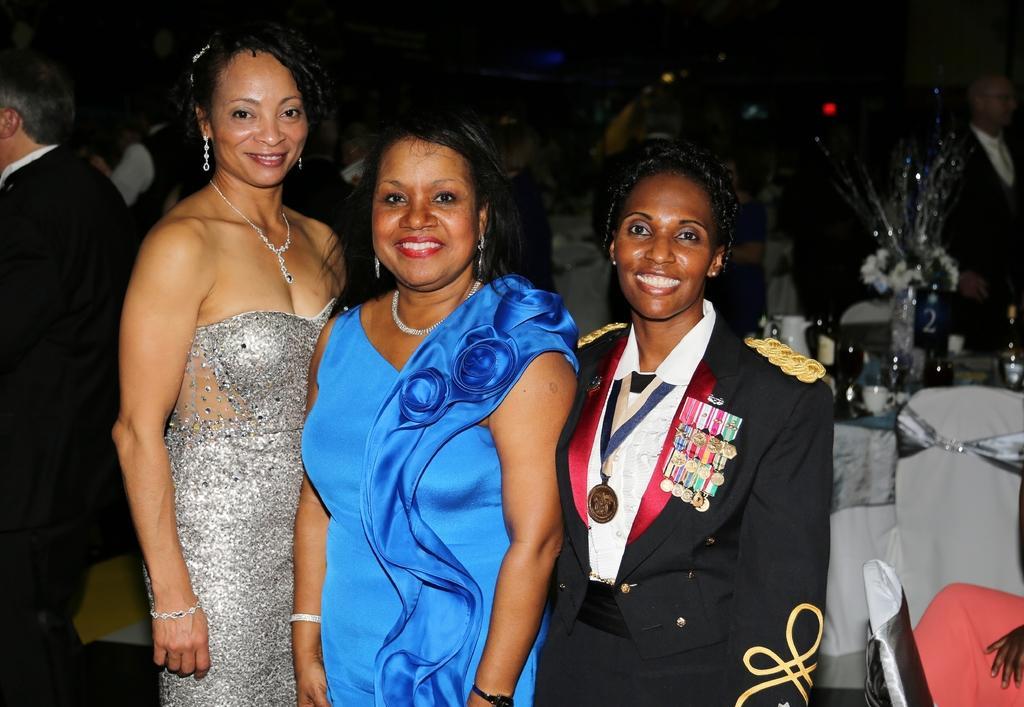How would you summarize this image in a sentence or two? In this image in the foreground three ladies are standing. They all are smiling. in the background on there are many people, tables, chairs. On the table there are bottles, cups, bouquet. 